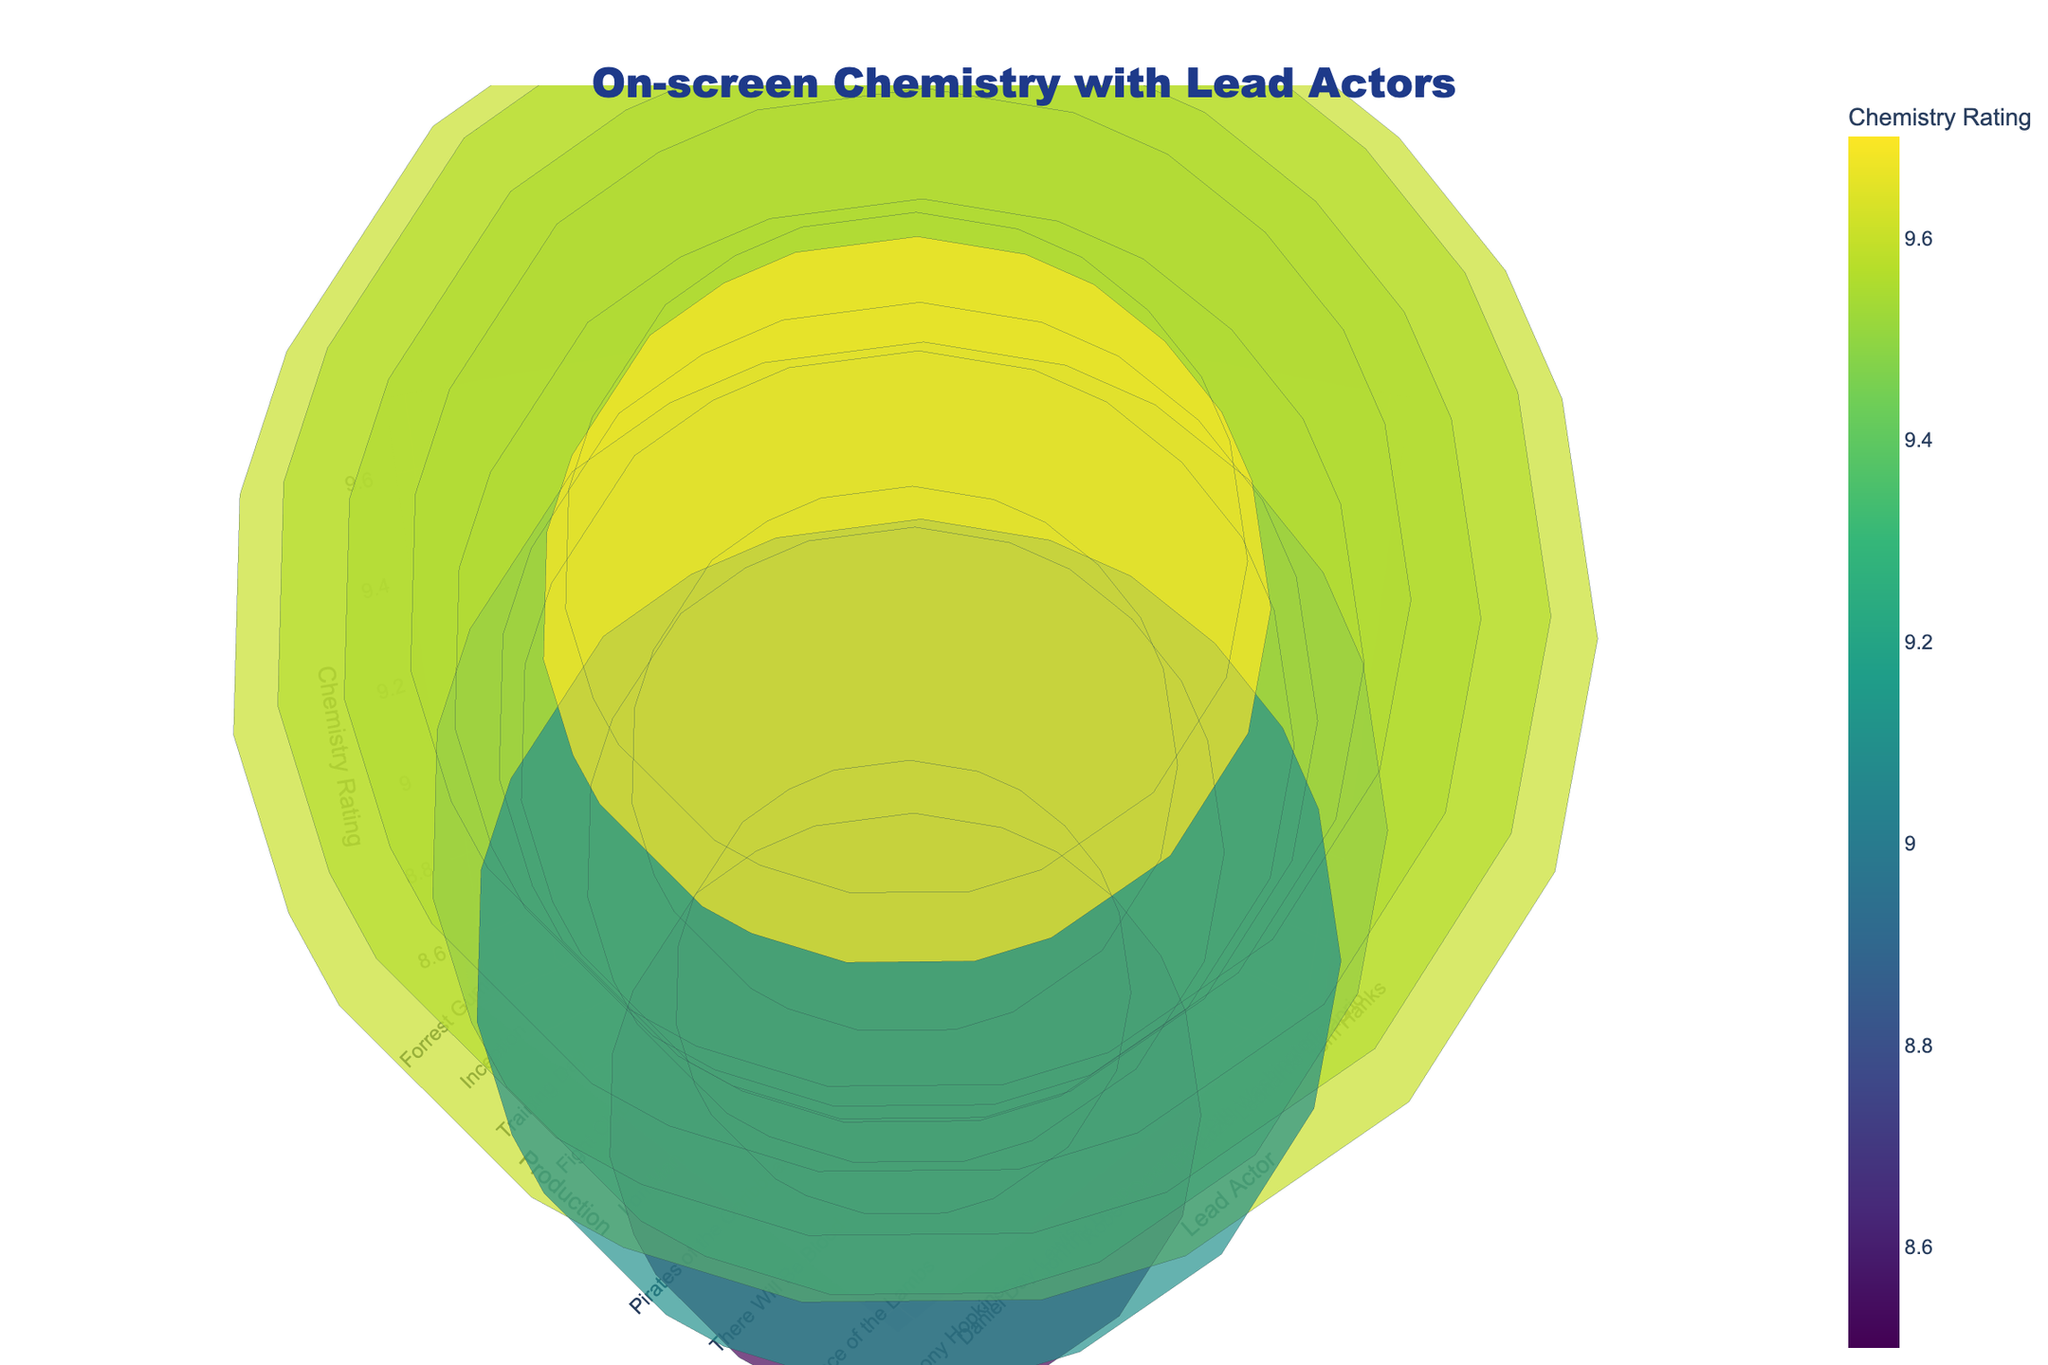How many data points are represented in the figure? You can count the number of bubbles plotted in the 3D bubble chart. Each bubble represents one data point.
Answer: 15 Which lead actor is associated with the highest on-screen chemistry rating? Identify the bubble that is positioned highest along the z-axis (Chemistry Rating). This bubble represents the actor with the highest rating.
Answer: Anthony Hopkins Which production corresponds to the largest bubble in the figure? The size of the bubble corresponds to the screen time in minutes. Look for the biggest bubble and check the associated production name from the hover data or labels.
Answer: There Will Be Blood Between Tom Hanks and Brad Pitt, who has a higher Chemistry Rating and by how much? Compare the z-axis (Chemistry Rating) positions of the bubbles representing Tom Hanks and Brad Pitt. Subtract the rating of Brad Pitt from that of Tom Hanks.
Answer: Tom Hanks by 0.4 For productions with a Chemistry Rating of 9.0 or above, how many have a Screen Time greater than 20 minutes? Look for bubbles with a z-axis value of 9.0 or higher and check if their size represents a screen time greater than 20 minutes from the hover data or labels.
Answer: 3 Compare the Chemistry Ratings of actors in productions “Iron Man” and “Black Swan”. Which one is higher and by how much? Find the bubbles representing these productions and compare their z-axis positions (Chemistry Ratings). Subtract the rating of “Iron Man” from that of “Black Swan”.
Answer: Black Swan by 0.5 Which factor has the most visual impact in distinguishing bubbles in this plot: Chemistry Rating, Screen Time, or Lead Actor? Assess the 3D bubble chart by considering the axis placement, bubble sizes, and color gradients. Chemistry Rating has a dedicated axis and a color scale, making it the visually most distinguishing feature.
Answer: Chemistry Rating 